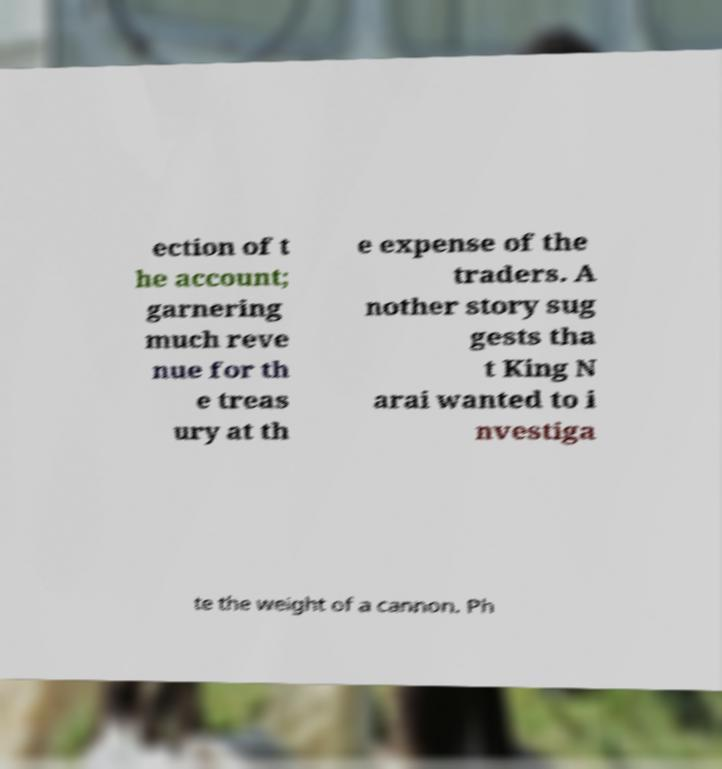Can you accurately transcribe the text from the provided image for me? ection of t he account; garnering much reve nue for th e treas ury at th e expense of the traders. A nother story sug gests tha t King N arai wanted to i nvestiga te the weight of a cannon. Ph 